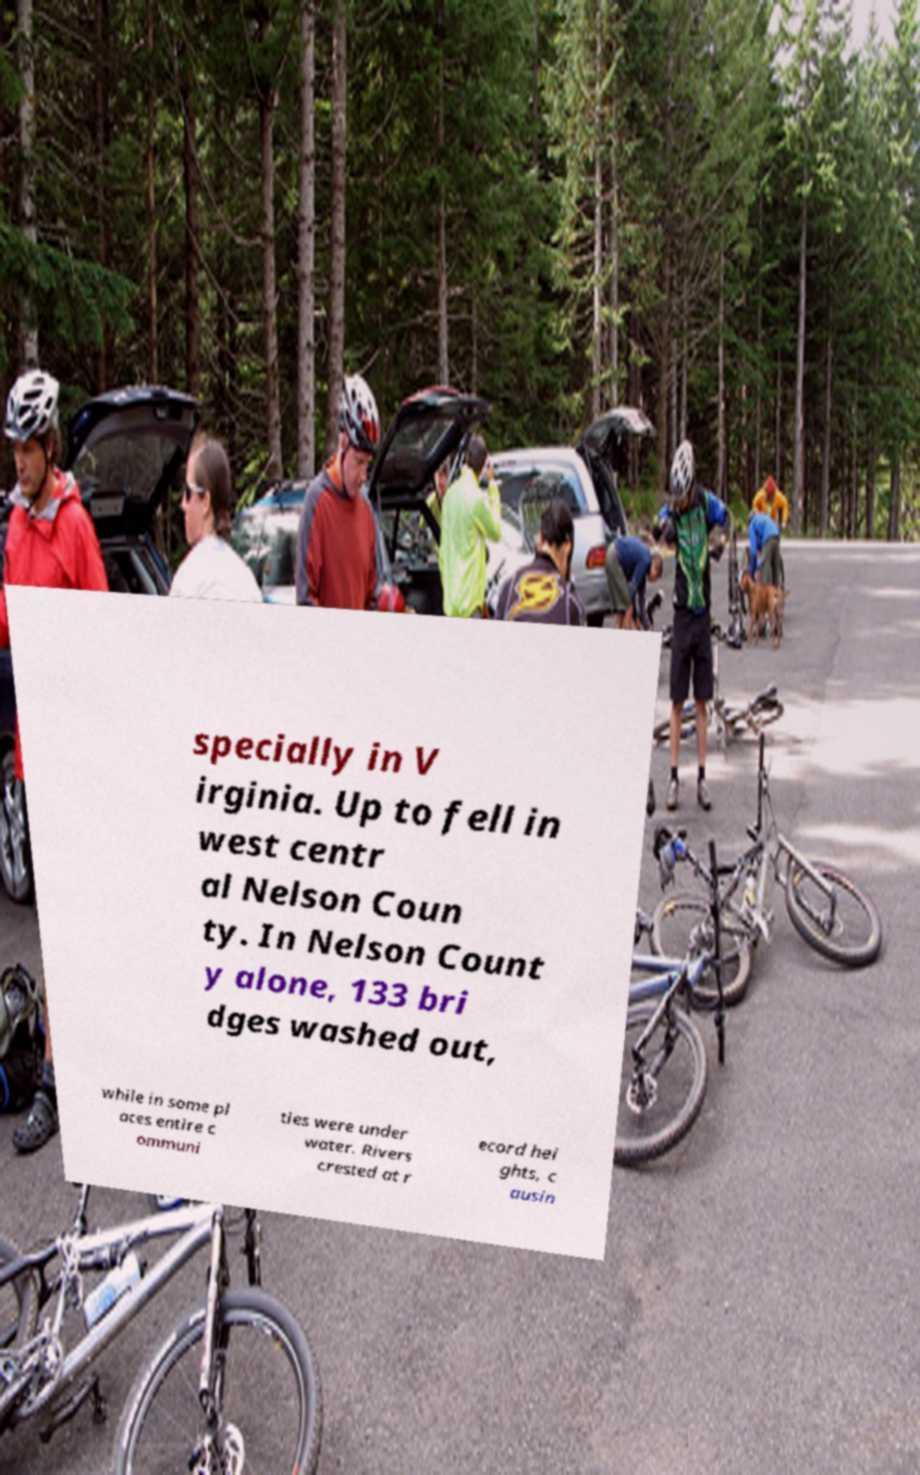Please read and relay the text visible in this image. What does it say? specially in V irginia. Up to fell in west centr al Nelson Coun ty. In Nelson Count y alone, 133 bri dges washed out, while in some pl aces entire c ommuni ties were under water. Rivers crested at r ecord hei ghts, c ausin 